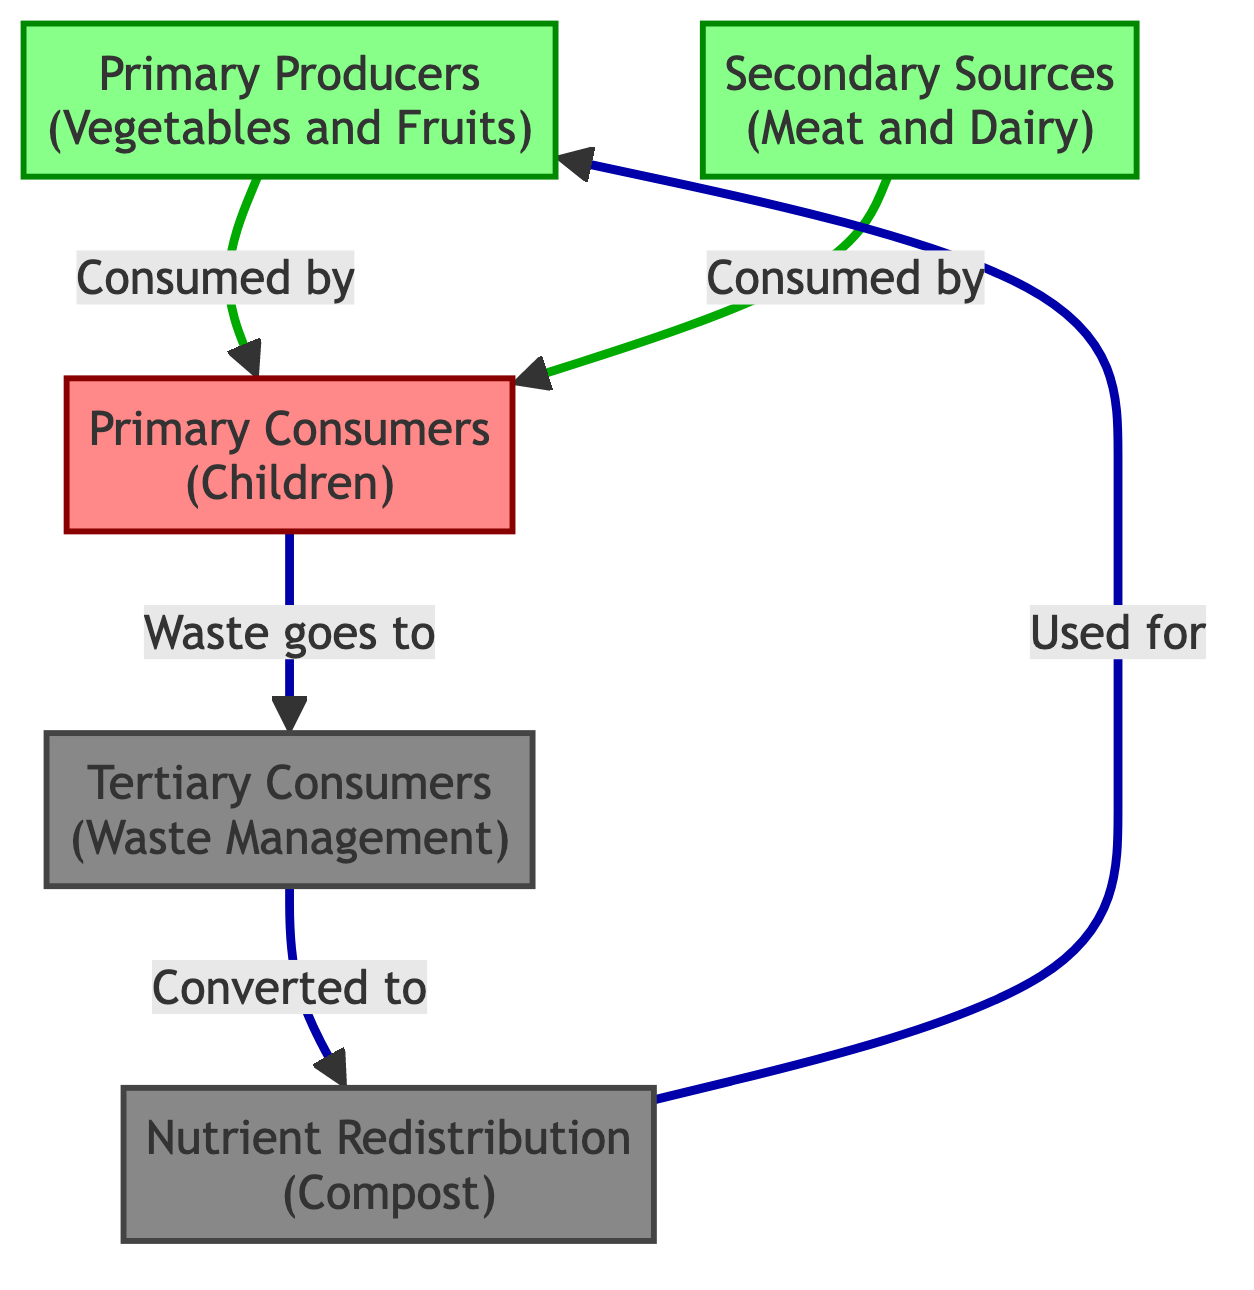What are the primary producers in this food chain? The diagram indicates that the primary producers are "Vegetables and Fruits," listed as node 1.
Answer: Vegetables and Fruits Who are the primary consumers in this diagram? The primary consumers are children, represented as node 2 in the diagram.
Answer: Children What do the waste generated by primary consumers become? The waste from primary consumers is directed to the waste management node (node 4), which is converted into compost (node 5).
Answer: Compost How many different types of consumers are present in the diagram? There are two types of consumers shown: primary consumers and tertiary consumers (waste management), counting them gives a total of 2 types.
Answer: 2 What is the flow of nutrients back to the primary producers? Nutrients flow from the compost (node 5) to the primary producers (node 1), indicating a recycling process in the food chain.
Answer: Primary Producers What connections do the primary consumers have with the secondary sources? The primary consumers (children) consume both the primary producers (vegetables and fruits) and secondary sources (meat and dairy), highlighting two direct consumption arrows pointing to node 2.
Answer: Two connections What is the ultimate fate of the waste generated by the system? The waste generated by primary consumers is transformed into compost via waste management, resulting in nutrient recycling for the primary producers.
Answer: Nutrient recycling What is the role of secondary sources in this food chain? The secondary sources (meat and dairy) serve as an additional food supply for the primary consumers (children), contributing to their nutrient intake.
Answer: Additional food supply Which node represents the waste management process? The waste management process is represented by node 4 in the diagram.
Answer: Waste Management 